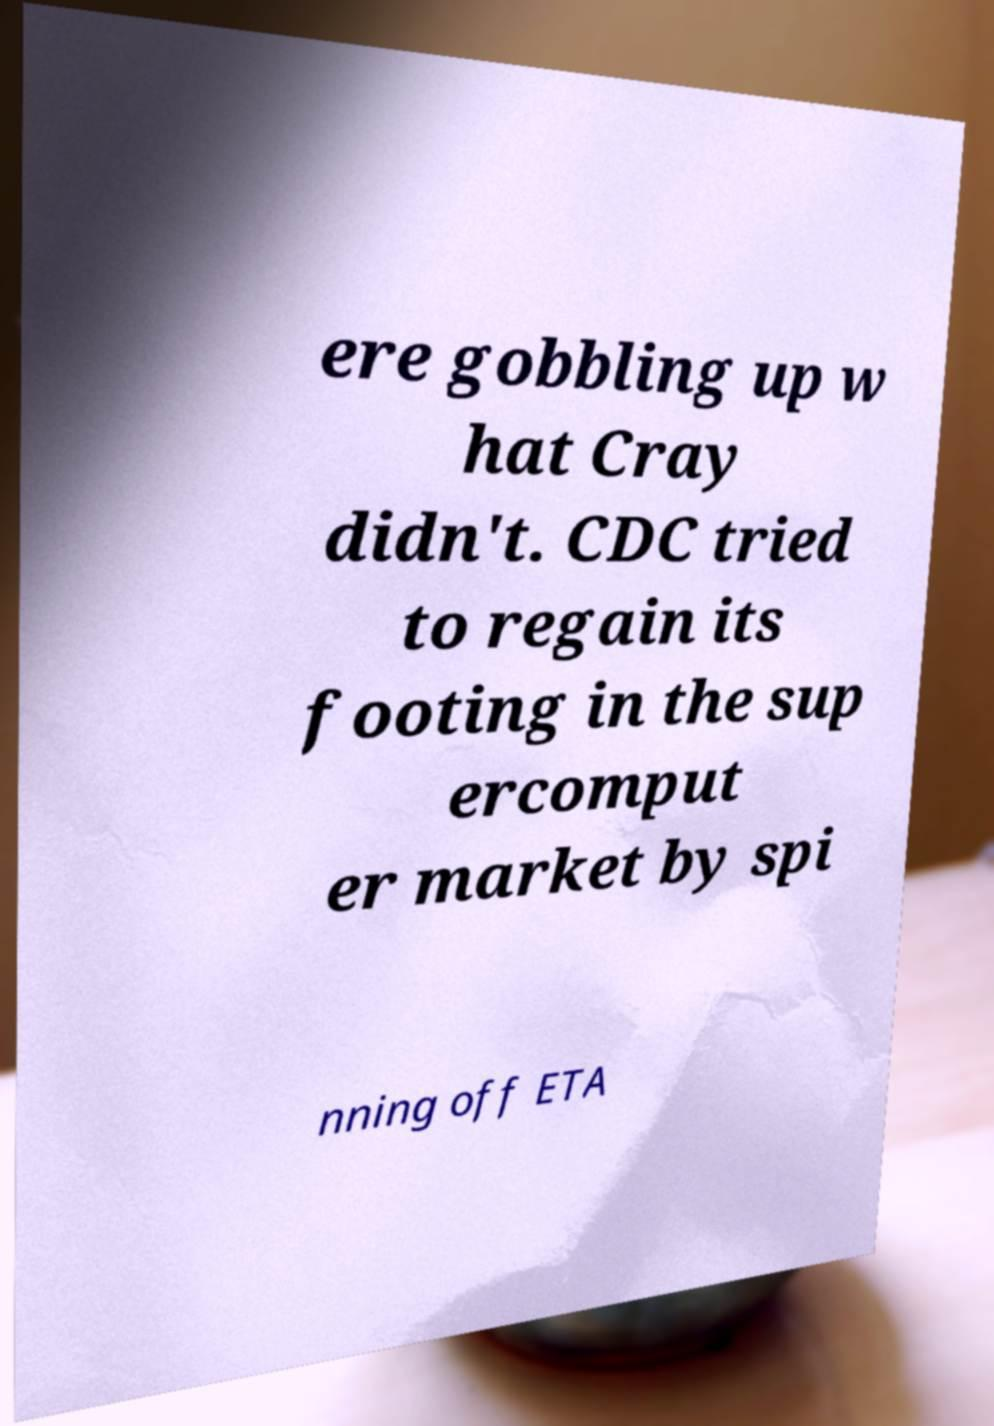Can you read and provide the text displayed in the image?This photo seems to have some interesting text. Can you extract and type it out for me? ere gobbling up w hat Cray didn't. CDC tried to regain its footing in the sup ercomput er market by spi nning off ETA 